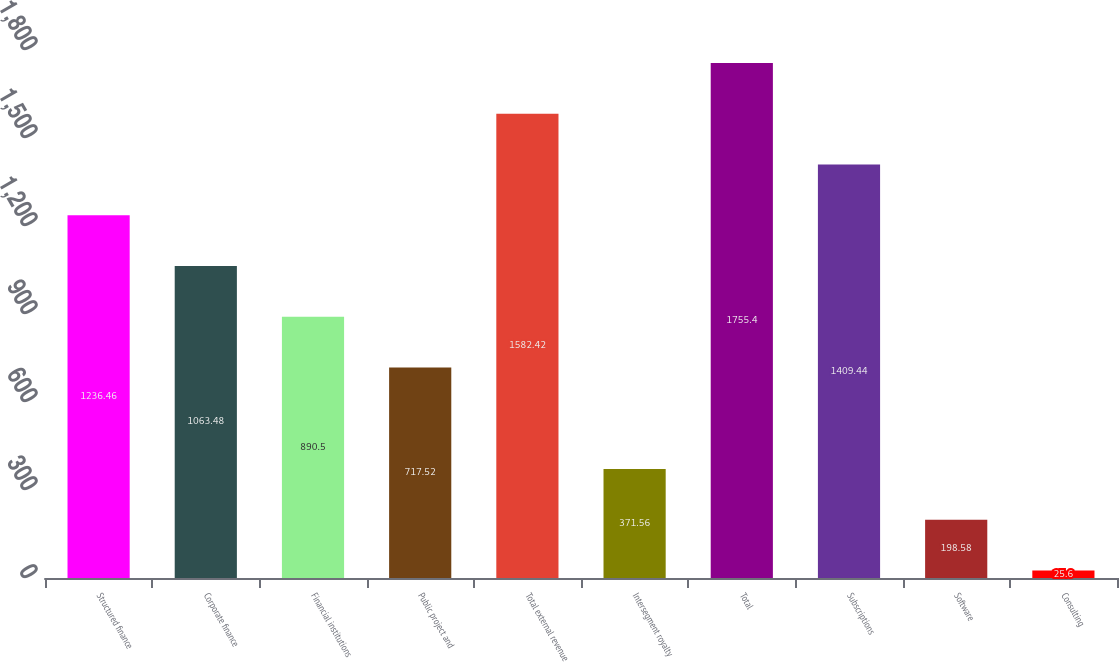Convert chart to OTSL. <chart><loc_0><loc_0><loc_500><loc_500><bar_chart><fcel>Structured finance<fcel>Corporate finance<fcel>Financial institutions<fcel>Public project and<fcel>Total external revenue<fcel>Intersegment royalty<fcel>Total<fcel>Subscriptions<fcel>Software<fcel>Consulting<nl><fcel>1236.46<fcel>1063.48<fcel>890.5<fcel>717.52<fcel>1582.42<fcel>371.56<fcel>1755.4<fcel>1409.44<fcel>198.58<fcel>25.6<nl></chart> 